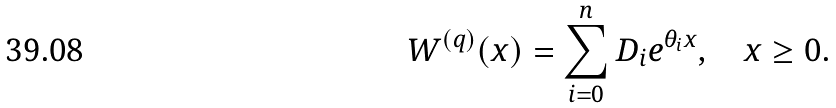Convert formula to latex. <formula><loc_0><loc_0><loc_500><loc_500>W ^ { ( q ) } ( x ) = \sum _ { i = 0 } ^ { n } D _ { i } e ^ { \theta _ { i } x } , \quad x \geq 0 .</formula> 